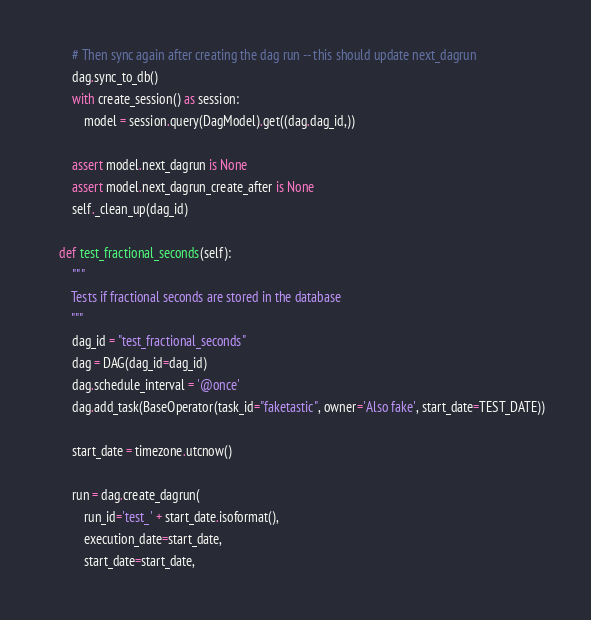<code> <loc_0><loc_0><loc_500><loc_500><_Python_>        # Then sync again after creating the dag run -- this should update next_dagrun
        dag.sync_to_db()
        with create_session() as session:
            model = session.query(DagModel).get((dag.dag_id,))

        assert model.next_dagrun is None
        assert model.next_dagrun_create_after is None
        self._clean_up(dag_id)

    def test_fractional_seconds(self):
        """
        Tests if fractional seconds are stored in the database
        """
        dag_id = "test_fractional_seconds"
        dag = DAG(dag_id=dag_id)
        dag.schedule_interval = '@once'
        dag.add_task(BaseOperator(task_id="faketastic", owner='Also fake', start_date=TEST_DATE))

        start_date = timezone.utcnow()

        run = dag.create_dagrun(
            run_id='test_' + start_date.isoformat(),
            execution_date=start_date,
            start_date=start_date,</code> 